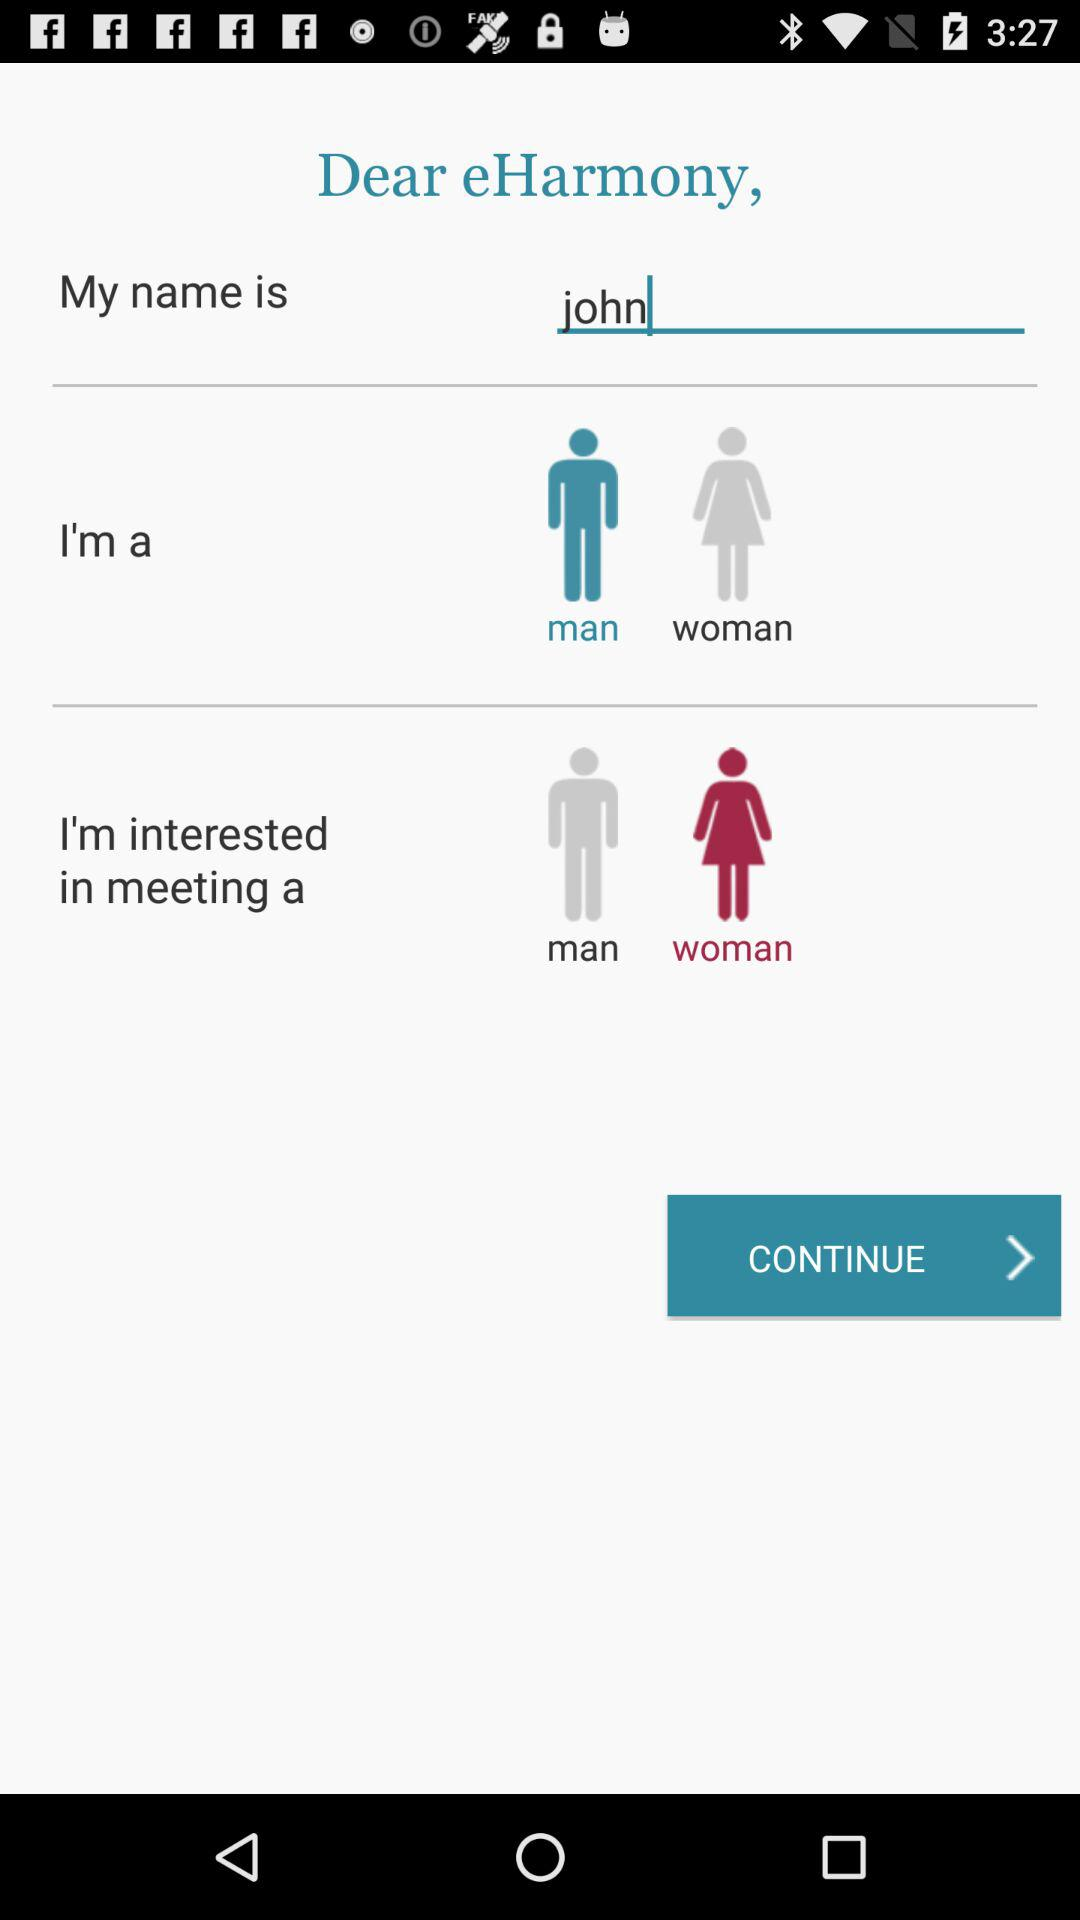Which option has been chosen for "I'm interested in meeting a"? The chosen option is "woman". 